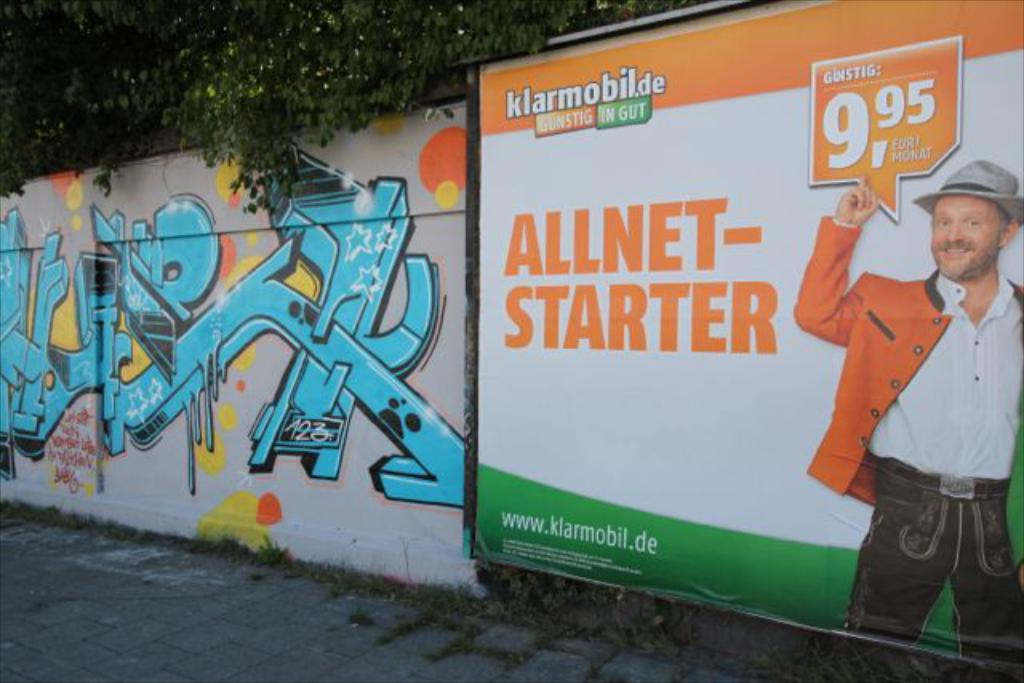Provide a one-sentence caption for the provided image. a billboard for All Net Starter has orange and green colors on it. 